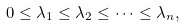Convert formula to latex. <formula><loc_0><loc_0><loc_500><loc_500>0 \leq \lambda _ { 1 } \leq \lambda _ { 2 } \leq \cdots \leq \lambda _ { n } ,</formula> 